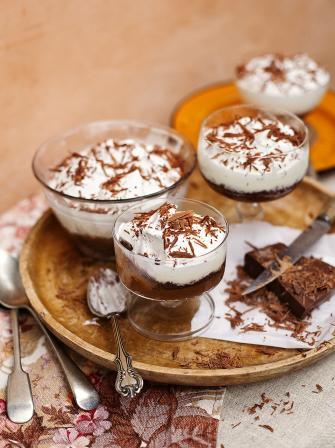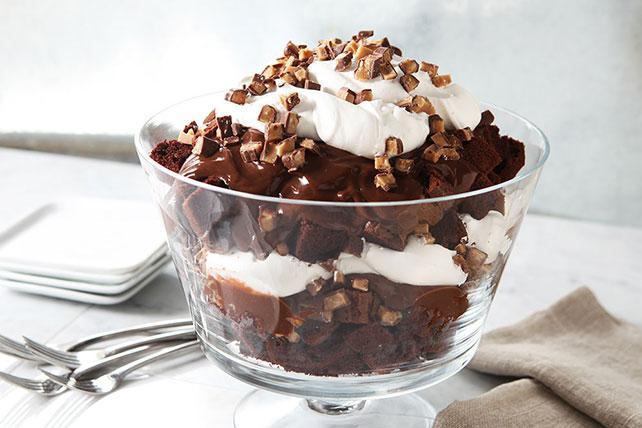The first image is the image on the left, the second image is the image on the right. For the images shown, is this caption "A dessert with a thick bottom chocolate layer and chocolate garnish on top is served in a non-footed glass." true? Answer yes or no. No. The first image is the image on the left, the second image is the image on the right. Assess this claim about the two images: "Two large layered desserts made with chocolate and creamy layers and topped with a garnish are in clear glass bowls, at least one of them footed.". Correct or not? Answer yes or no. No. 